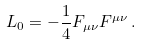<formula> <loc_0><loc_0><loc_500><loc_500>L _ { 0 } = - \frac { 1 } { 4 } F _ { \mu \nu } F ^ { \mu \nu } \, .</formula> 